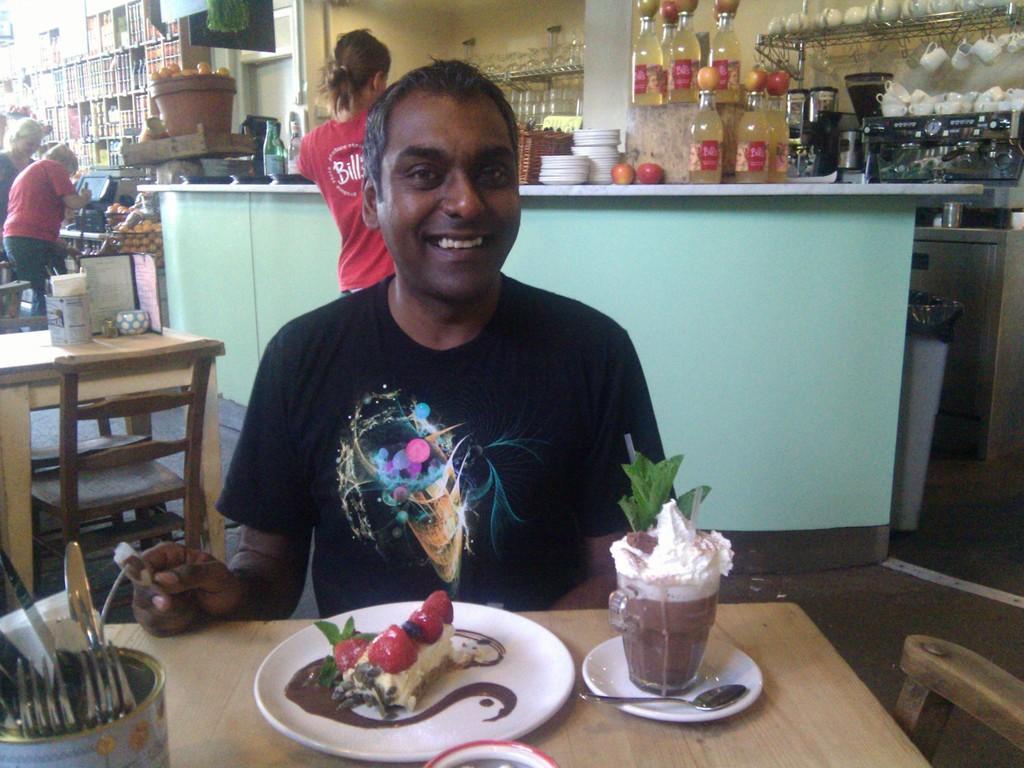Could you give a brief overview of what you see in this image? Here we can see a man laughing sitting on a chair with a table in front of him having cakes and juices present on the plate and there are forks present and behind him we can see tables and chairs and there are persons standing and there are bottles of juices present in the rack 